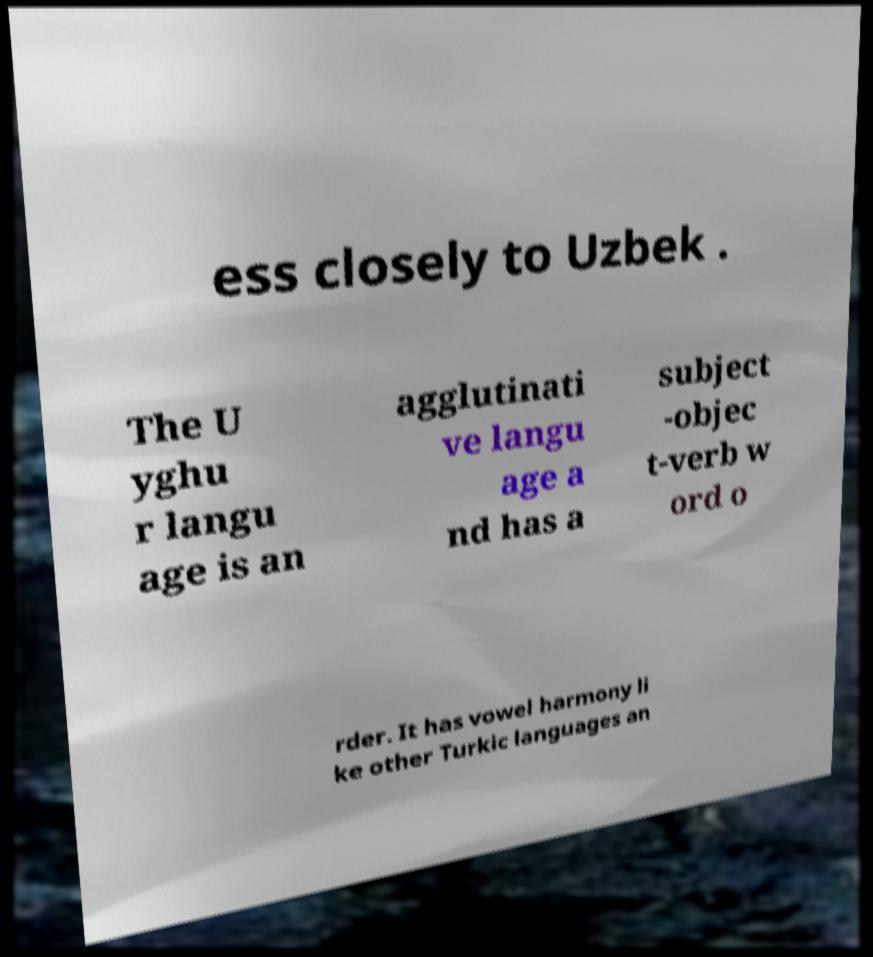Can you accurately transcribe the text from the provided image for me? ess closely to Uzbek . The U yghu r langu age is an agglutinati ve langu age a nd has a subject -objec t-verb w ord o rder. It has vowel harmony li ke other Turkic languages an 